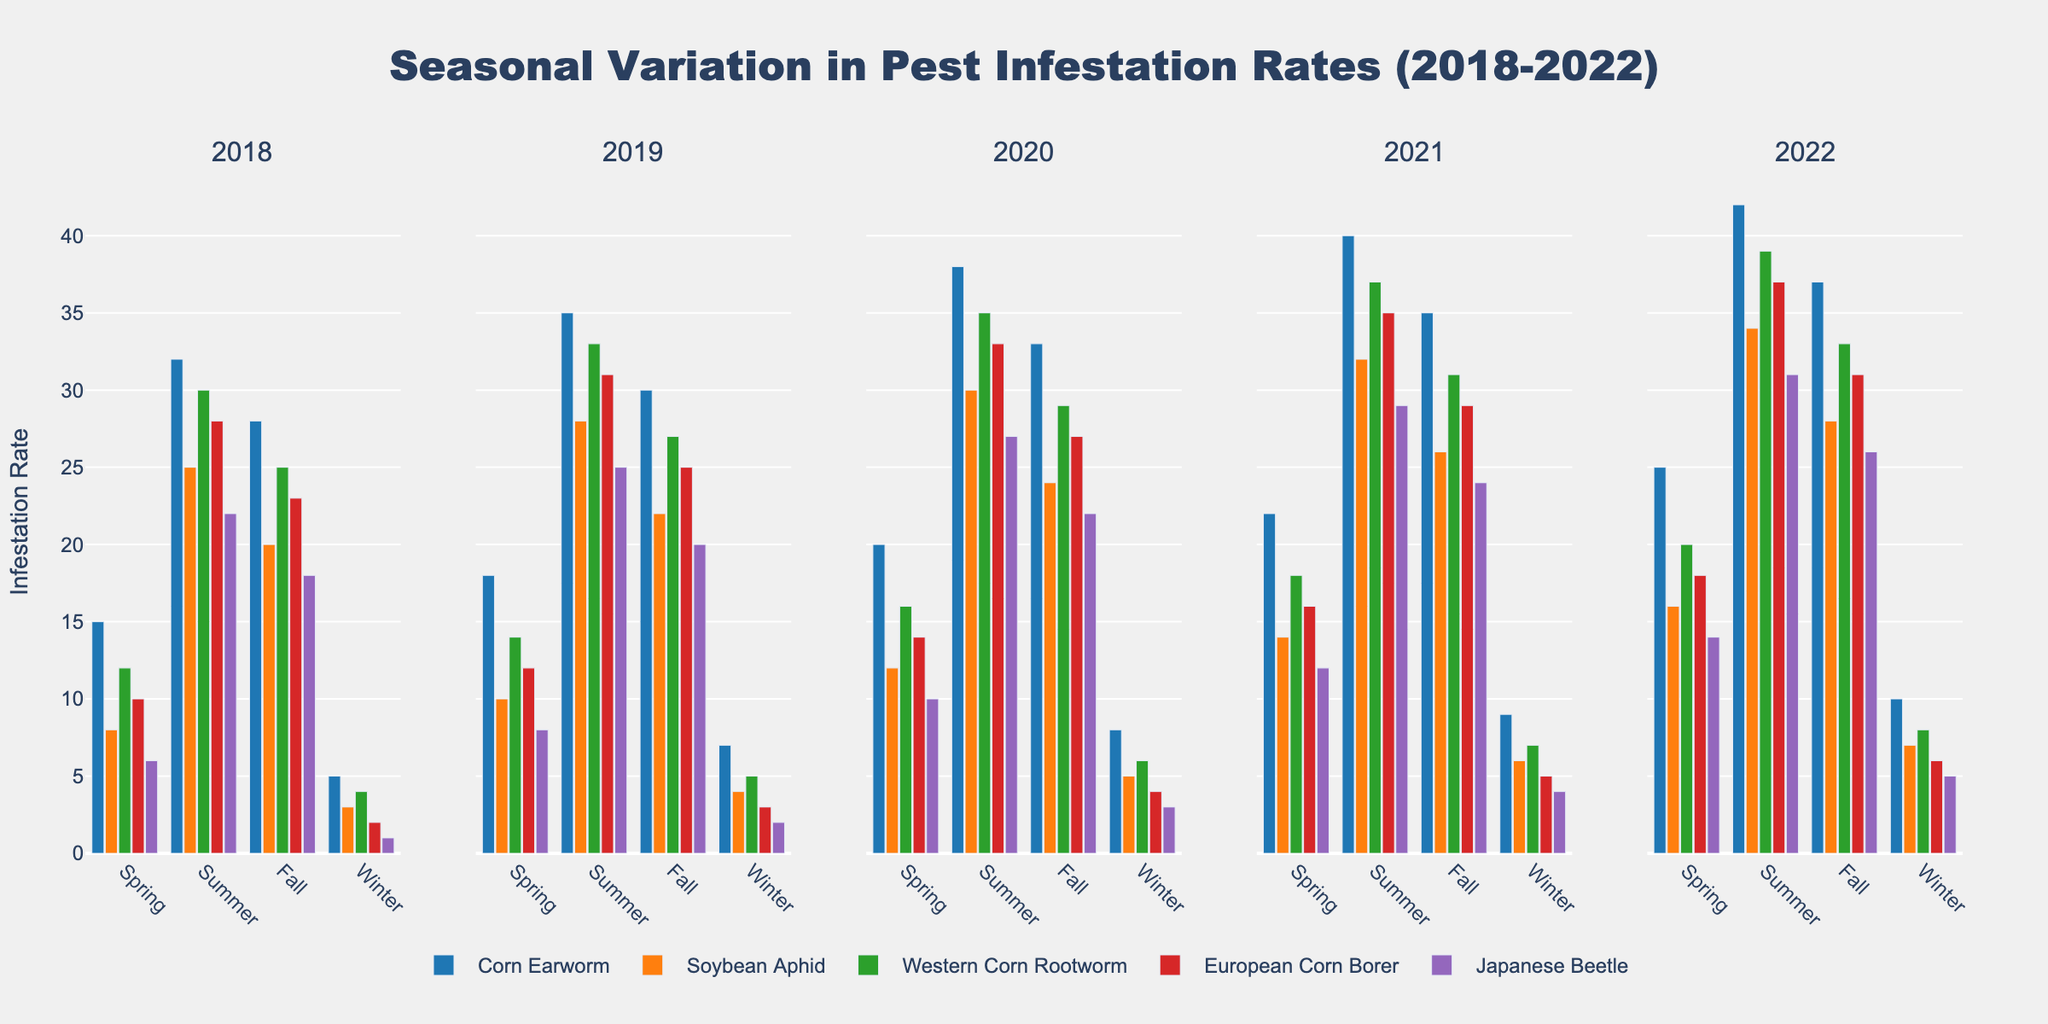What is the infestation rate of Corn Earworm in Spring 2020? Observing the section for Spring 2020, the Corn Earworm bar height represents an infestation rate of 20.
Answer: 20 Which pest had the highest infestation rate in Summer 2022? In the Summer 2022 section, the bar for Corn Earworm is the tallest, indicating the highest infestation rate among the pests.
Answer: Corn Earworm How did the infestation rate of Soybean Aphid change from Spring to Fall in 2021? Looking at the Spring 2021 and Fall 2021 sections, the infestation rate of Soybean Aphid increased from 14 to 26.
Answer: Increased What is the average infestation rate of European Corn Borer across the winters from 2018 to 2022? The winter infestation rates for European Corn Borer are 2, 3, 4, 5, and 6 respectively. Summing these gives 20, and the average is 20 divided by 5 years.
Answer: 4 Which season had the least infestation rates overall for Western Corn Rootworm in 2020? Checking the 2020 section, Winter has the smallest bar height for Western Corn Rootworm, indicating the lowest infestation rate for the year.
Answer: Winter How does the infestation rate of Japanese Beetle in Fall 2019 compare to Fall 2022? The infestation rate for Japanese Beetle in Fall 2019 is 20 and in Fall 2022 is 26. The difference is 26 - 20.
Answer: Higher by 6 What is the difference in infestation rates of Corn Earworm between Summer 2019 and Summer 2021? The infestation rates for Corn Earworm are 35 in Summer 2019 and 40 in Summer 2021. The difference is 40 - 35.
Answer: 5 Which pest shows the most significant increase in infestation rate from Summer 2018 to Summer 2019? Comparing the infestation rates from Summer 2018 to Summer 2019 for each pest, Corn Earworm increases from 32 to 35, Soybean Aphid from 25 to 28, Western Corn Rootworm from 30 to 33, European Corn Borer from 28 to 31, and Japanese Beetle from 22 to 25. The greatest increase is for Corn Earworm.
Answer: Corn Earworm 